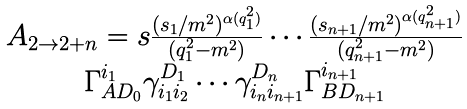<formula> <loc_0><loc_0><loc_500><loc_500>\begin{array} { c } { { A _ { 2 \rightarrow 2 + n } = s \frac { ( s _ { 1 } / m ^ { 2 } ) ^ { \alpha ( q _ { 1 } ^ { 2 } ) } } { ( q _ { 1 } ^ { 2 } - m ^ { 2 } ) } \cdots \frac { ( s _ { n + 1 } / m ^ { 2 } ) ^ { \alpha ( q _ { n + 1 } ^ { 2 } ) } } { ( q _ { n + 1 } ^ { 2 } - m ^ { 2 } ) } } } \\ { { \Gamma _ { A D _ { 0 } } ^ { i _ { 1 } } \gamma _ { i _ { 1 } i _ { 2 } } ^ { D _ { 1 } } \cdots \gamma _ { i _ { n } i _ { n + 1 } } ^ { D _ { n } } \Gamma _ { B D _ { n + 1 } } ^ { i _ { n + 1 } } } } \end{array}</formula> 